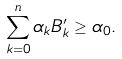Convert formula to latex. <formula><loc_0><loc_0><loc_500><loc_500>\sum _ { k = 0 } ^ { n } \alpha _ { k } B ^ { \prime } _ { k } \geq \alpha _ { 0 } .</formula> 